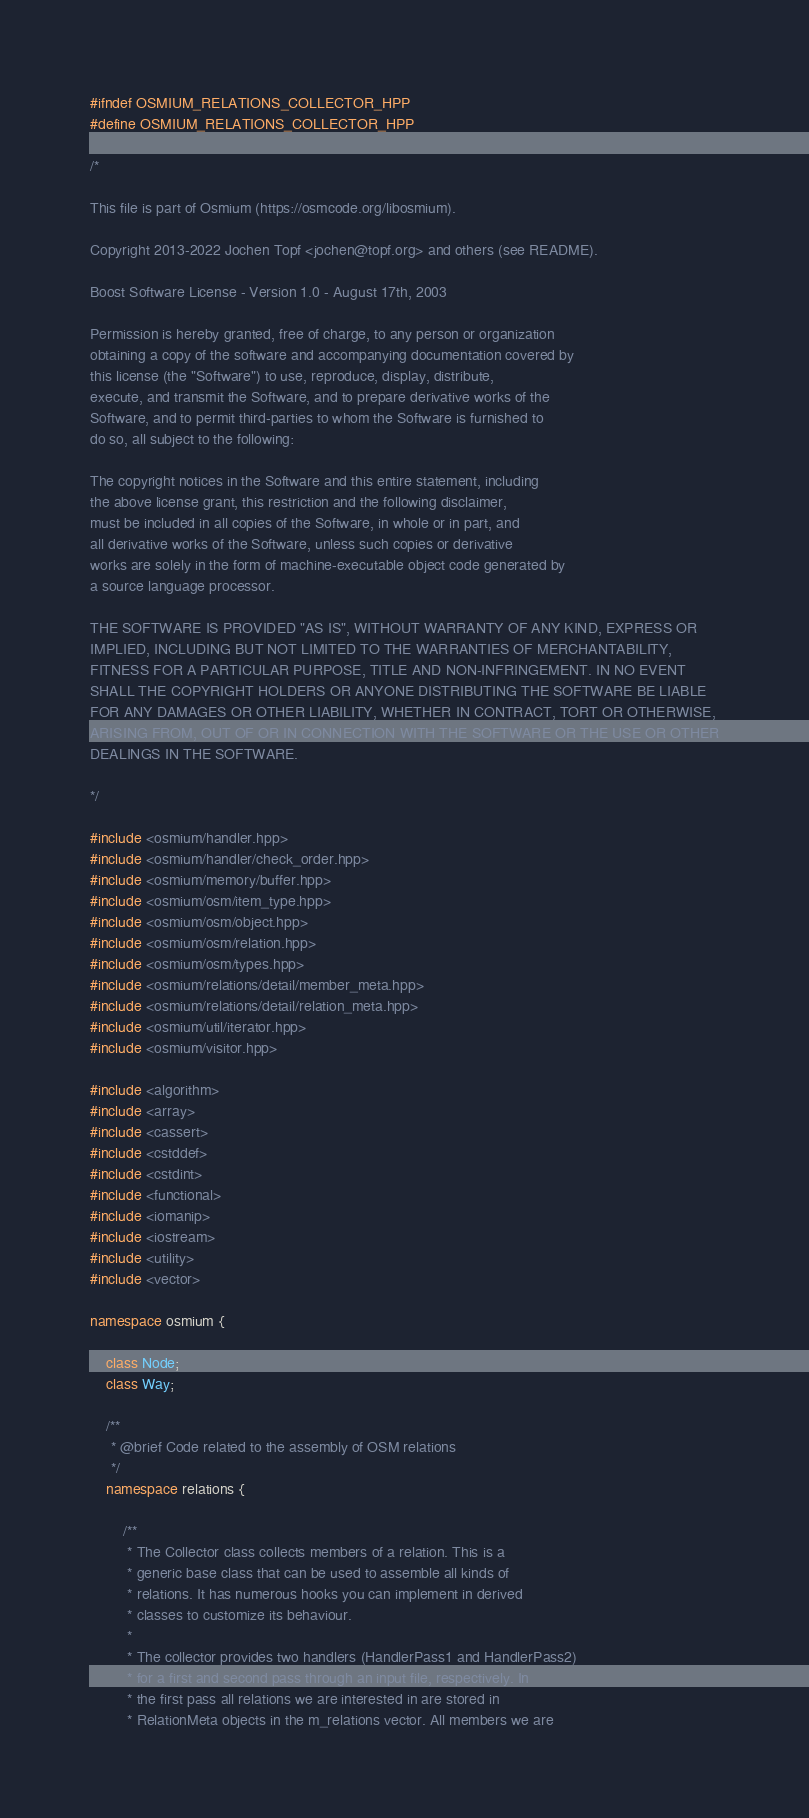<code> <loc_0><loc_0><loc_500><loc_500><_C++_>#ifndef OSMIUM_RELATIONS_COLLECTOR_HPP
#define OSMIUM_RELATIONS_COLLECTOR_HPP

/*

This file is part of Osmium (https://osmcode.org/libosmium).

Copyright 2013-2022 Jochen Topf <jochen@topf.org> and others (see README).

Boost Software License - Version 1.0 - August 17th, 2003

Permission is hereby granted, free of charge, to any person or organization
obtaining a copy of the software and accompanying documentation covered by
this license (the "Software") to use, reproduce, display, distribute,
execute, and transmit the Software, and to prepare derivative works of the
Software, and to permit third-parties to whom the Software is furnished to
do so, all subject to the following:

The copyright notices in the Software and this entire statement, including
the above license grant, this restriction and the following disclaimer,
must be included in all copies of the Software, in whole or in part, and
all derivative works of the Software, unless such copies or derivative
works are solely in the form of machine-executable object code generated by
a source language processor.

THE SOFTWARE IS PROVIDED "AS IS", WITHOUT WARRANTY OF ANY KIND, EXPRESS OR
IMPLIED, INCLUDING BUT NOT LIMITED TO THE WARRANTIES OF MERCHANTABILITY,
FITNESS FOR A PARTICULAR PURPOSE, TITLE AND NON-INFRINGEMENT. IN NO EVENT
SHALL THE COPYRIGHT HOLDERS OR ANYONE DISTRIBUTING THE SOFTWARE BE LIABLE
FOR ANY DAMAGES OR OTHER LIABILITY, WHETHER IN CONTRACT, TORT OR OTHERWISE,
ARISING FROM, OUT OF OR IN CONNECTION WITH THE SOFTWARE OR THE USE OR OTHER
DEALINGS IN THE SOFTWARE.

*/

#include <osmium/handler.hpp>
#include <osmium/handler/check_order.hpp>
#include <osmium/memory/buffer.hpp>
#include <osmium/osm/item_type.hpp>
#include <osmium/osm/object.hpp>
#include <osmium/osm/relation.hpp>
#include <osmium/osm/types.hpp>
#include <osmium/relations/detail/member_meta.hpp>
#include <osmium/relations/detail/relation_meta.hpp>
#include <osmium/util/iterator.hpp>
#include <osmium/visitor.hpp>

#include <algorithm>
#include <array>
#include <cassert>
#include <cstddef>
#include <cstdint>
#include <functional>
#include <iomanip>
#include <iostream>
#include <utility>
#include <vector>

namespace osmium {

    class Node;
    class Way;

    /**
     * @brief Code related to the assembly of OSM relations
     */
    namespace relations {

        /**
         * The Collector class collects members of a relation. This is a
         * generic base class that can be used to assemble all kinds of
         * relations. It has numerous hooks you can implement in derived
         * classes to customize its behaviour.
         *
         * The collector provides two handlers (HandlerPass1 and HandlerPass2)
         * for a first and second pass through an input file, respectively. In
         * the first pass all relations we are interested in are stored in
         * RelationMeta objects in the m_relations vector. All members we are</code> 